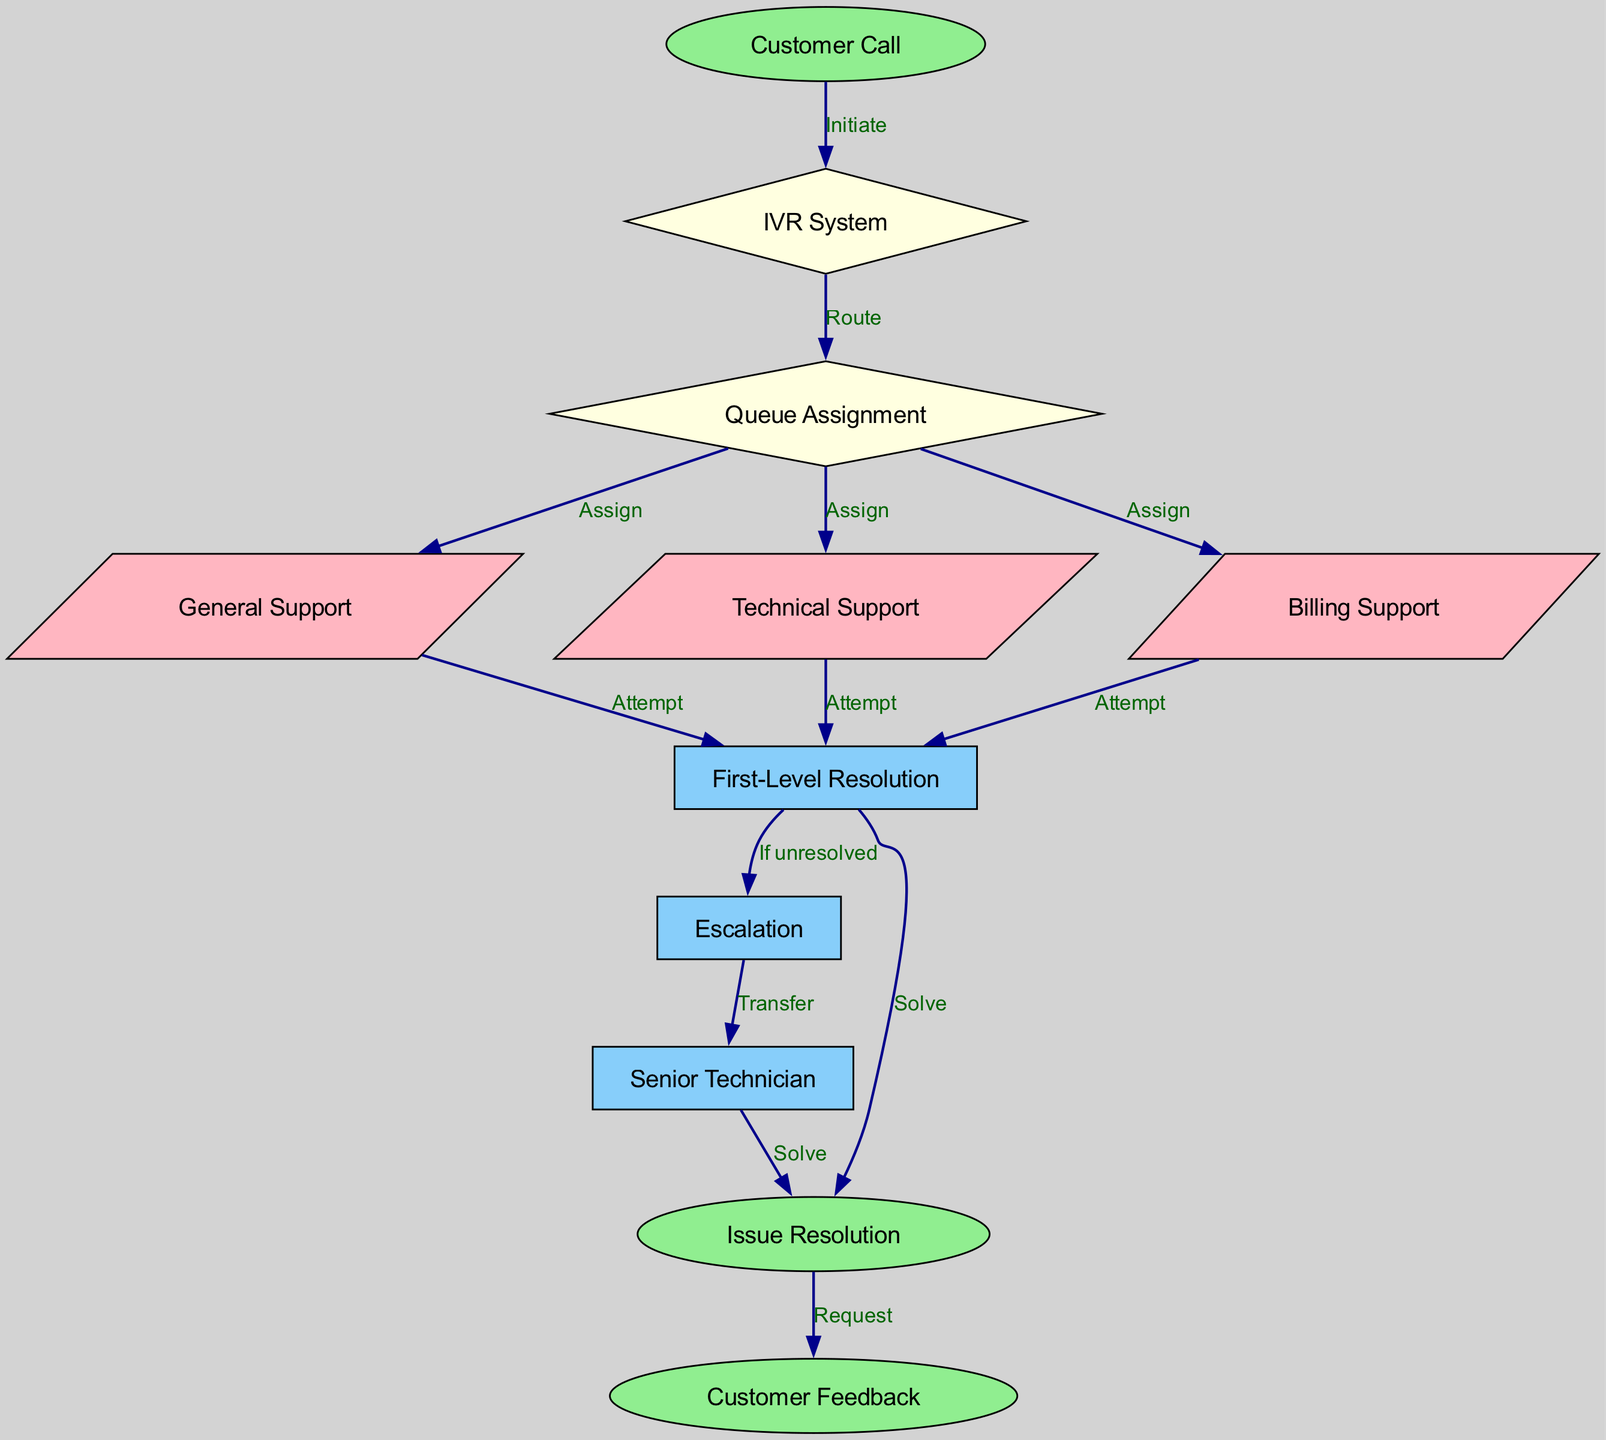What is the starting point of the call routing process? The diagram shows that the starting point is "Customer Call," which is the first node that initiates the process.
Answer: Customer Call How many support types are available after "Queue Assignment"? There are three support types available: "General Support," "Technical Support," and "Billing Support," which can be identified as incoming edges from "Queue Assignment."
Answer: Three What happens if the issue cannot be resolved at "First-Level Resolution"? The diagram indicates that if the issue is unresolved, it leads to "Escalation," marking the next step in the process where the issue is transferred.
Answer: Escalation Which node represents the final step before customer feedback? The final step before customer feedback is "Issue Resolution," which is directly connected to the "Customer Feedback" node, indicating the resolution has been provided to the customer.
Answer: Issue Resolution What is the shape of the "IVR System" node? In the diagram, the "IVR System" node is represented as a diamond shape, indicating its role as a decision point in the call process.
Answer: Diamond How many edges are there leading from "Queue Assignment"? There are three edges leading from "Queue Assignment," each assigning a different type of support: General, Technical, and Billing Support.
Answer: Three At which point is a senior technician involved? The senior technician is involved after "Escalation," which indicates a transfer to "Senior Technician" for further assistance with unresolved issues.
Answer: Senior Technician What action is taken after resolving the issue? After resolving the issue, the action taken is to request "Customer Feedback," which denotes the end of the customer service call process.
Answer: Request What type of node is "First-Level Resolution"? "First-Level Resolution" is represented as a parallelogram in the diagram, signifying its function as a support step in resolving customer issues.
Answer: Parallelogram 